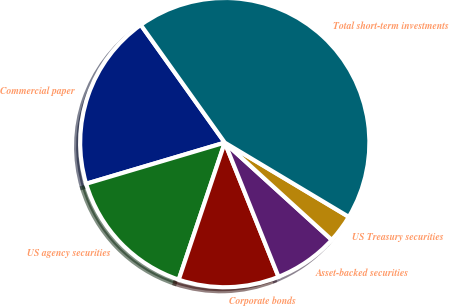Convert chart. <chart><loc_0><loc_0><loc_500><loc_500><pie_chart><fcel>Commercial paper<fcel>US agency securities<fcel>Corporate bonds<fcel>Asset-backed securities<fcel>US Treasury securities<fcel>Total short-term investments<nl><fcel>19.73%<fcel>15.25%<fcel>11.22%<fcel>7.19%<fcel>3.16%<fcel>43.45%<nl></chart> 